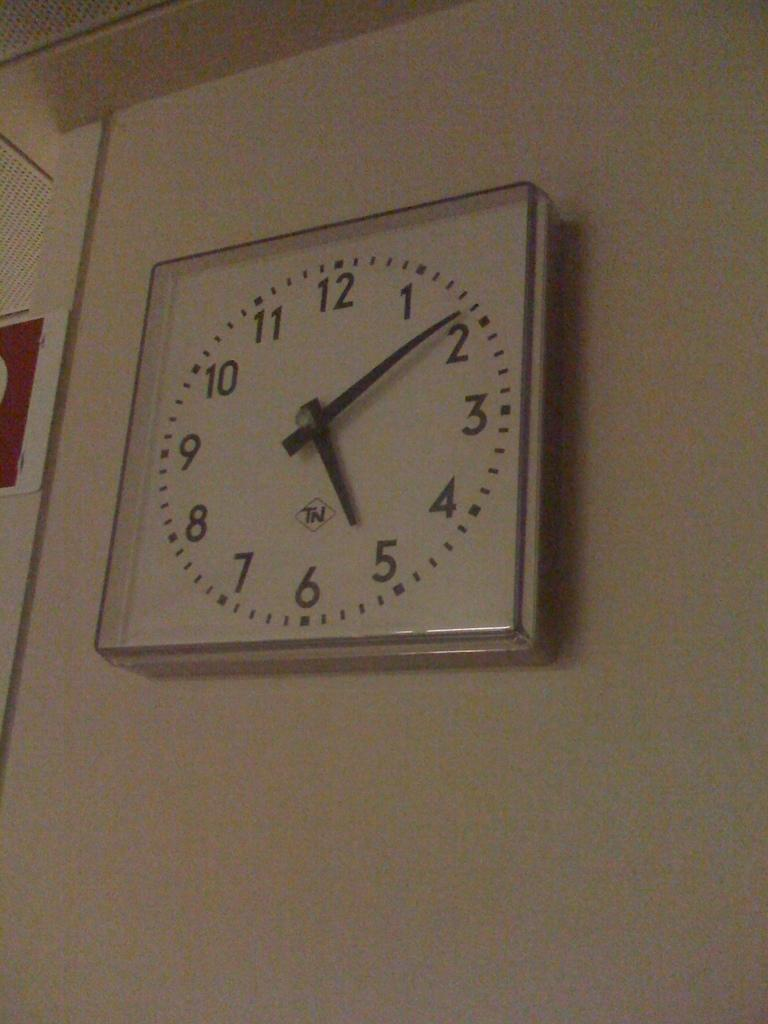<image>
Relay a brief, clear account of the picture shown. A clock hangs on the wall and has the letters TN on it. 